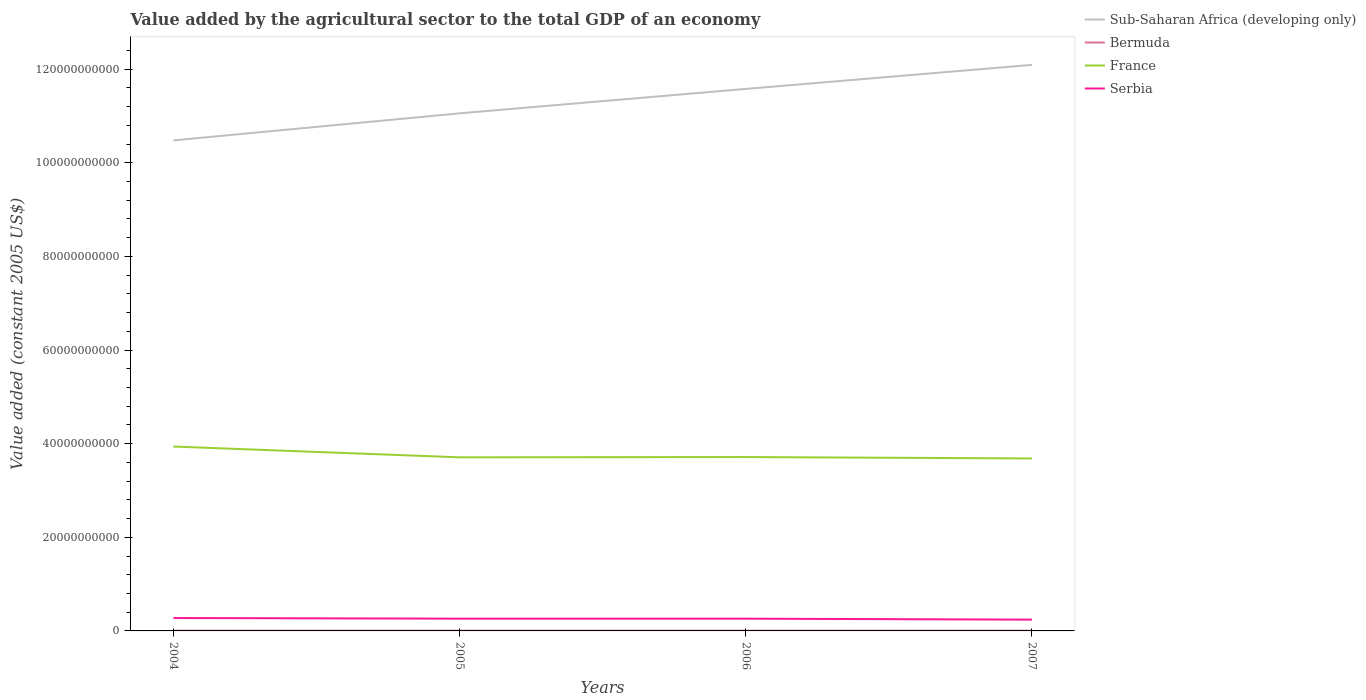How many different coloured lines are there?
Ensure brevity in your answer.  4. Is the number of lines equal to the number of legend labels?
Provide a short and direct response. Yes. Across all years, what is the maximum value added by the agricultural sector in Bermuda?
Offer a terse response. 3.85e+07. What is the total value added by the agricultural sector in Sub-Saharan Africa (developing only) in the graph?
Your answer should be very brief. -5.14e+09. What is the difference between the highest and the second highest value added by the agricultural sector in Bermuda?
Your answer should be compact. 5.64e+06. How many lines are there?
Give a very brief answer. 4. How many years are there in the graph?
Ensure brevity in your answer.  4. What is the difference between two consecutive major ticks on the Y-axis?
Offer a very short reply. 2.00e+1. Does the graph contain grids?
Your answer should be very brief. No. What is the title of the graph?
Your answer should be very brief. Value added by the agricultural sector to the total GDP of an economy. What is the label or title of the Y-axis?
Offer a terse response. Value added (constant 2005 US$). What is the Value added (constant 2005 US$) in Sub-Saharan Africa (developing only) in 2004?
Make the answer very short. 1.05e+11. What is the Value added (constant 2005 US$) of Bermuda in 2004?
Offer a very short reply. 3.85e+07. What is the Value added (constant 2005 US$) in France in 2004?
Offer a very short reply. 3.94e+1. What is the Value added (constant 2005 US$) in Serbia in 2004?
Make the answer very short. 2.75e+09. What is the Value added (constant 2005 US$) of Sub-Saharan Africa (developing only) in 2005?
Keep it short and to the point. 1.11e+11. What is the Value added (constant 2005 US$) of Bermuda in 2005?
Your answer should be very brief. 3.90e+07. What is the Value added (constant 2005 US$) in France in 2005?
Your response must be concise. 3.71e+1. What is the Value added (constant 2005 US$) of Serbia in 2005?
Your answer should be compact. 2.62e+09. What is the Value added (constant 2005 US$) in Sub-Saharan Africa (developing only) in 2006?
Keep it short and to the point. 1.16e+11. What is the Value added (constant 2005 US$) of Bermuda in 2006?
Keep it short and to the point. 4.24e+07. What is the Value added (constant 2005 US$) in France in 2006?
Ensure brevity in your answer.  3.71e+1. What is the Value added (constant 2005 US$) in Serbia in 2006?
Your answer should be compact. 2.62e+09. What is the Value added (constant 2005 US$) in Sub-Saharan Africa (developing only) in 2007?
Your answer should be very brief. 1.21e+11. What is the Value added (constant 2005 US$) in Bermuda in 2007?
Make the answer very short. 4.42e+07. What is the Value added (constant 2005 US$) of France in 2007?
Keep it short and to the point. 3.68e+1. What is the Value added (constant 2005 US$) in Serbia in 2007?
Your response must be concise. 2.41e+09. Across all years, what is the maximum Value added (constant 2005 US$) of Sub-Saharan Africa (developing only)?
Your answer should be very brief. 1.21e+11. Across all years, what is the maximum Value added (constant 2005 US$) of Bermuda?
Ensure brevity in your answer.  4.42e+07. Across all years, what is the maximum Value added (constant 2005 US$) of France?
Your answer should be very brief. 3.94e+1. Across all years, what is the maximum Value added (constant 2005 US$) of Serbia?
Give a very brief answer. 2.75e+09. Across all years, what is the minimum Value added (constant 2005 US$) of Sub-Saharan Africa (developing only)?
Your answer should be compact. 1.05e+11. Across all years, what is the minimum Value added (constant 2005 US$) of Bermuda?
Keep it short and to the point. 3.85e+07. Across all years, what is the minimum Value added (constant 2005 US$) in France?
Your answer should be compact. 3.68e+1. Across all years, what is the minimum Value added (constant 2005 US$) in Serbia?
Your response must be concise. 2.41e+09. What is the total Value added (constant 2005 US$) of Sub-Saharan Africa (developing only) in the graph?
Your answer should be compact. 4.52e+11. What is the total Value added (constant 2005 US$) of Bermuda in the graph?
Offer a terse response. 1.64e+08. What is the total Value added (constant 2005 US$) in France in the graph?
Offer a terse response. 1.50e+11. What is the total Value added (constant 2005 US$) of Serbia in the graph?
Provide a succinct answer. 1.04e+1. What is the difference between the Value added (constant 2005 US$) in Sub-Saharan Africa (developing only) in 2004 and that in 2005?
Provide a short and direct response. -5.78e+09. What is the difference between the Value added (constant 2005 US$) in Bermuda in 2004 and that in 2005?
Keep it short and to the point. -4.91e+05. What is the difference between the Value added (constant 2005 US$) of France in 2004 and that in 2005?
Offer a very short reply. 2.30e+09. What is the difference between the Value added (constant 2005 US$) of Serbia in 2004 and that in 2005?
Your answer should be very brief. 1.33e+08. What is the difference between the Value added (constant 2005 US$) of Sub-Saharan Africa (developing only) in 2004 and that in 2006?
Give a very brief answer. -1.10e+1. What is the difference between the Value added (constant 2005 US$) of Bermuda in 2004 and that in 2006?
Offer a very short reply. -3.91e+06. What is the difference between the Value added (constant 2005 US$) in France in 2004 and that in 2006?
Ensure brevity in your answer.  2.24e+09. What is the difference between the Value added (constant 2005 US$) in Serbia in 2004 and that in 2006?
Offer a very short reply. 1.35e+08. What is the difference between the Value added (constant 2005 US$) of Sub-Saharan Africa (developing only) in 2004 and that in 2007?
Your answer should be very brief. -1.61e+1. What is the difference between the Value added (constant 2005 US$) of Bermuda in 2004 and that in 2007?
Keep it short and to the point. -5.64e+06. What is the difference between the Value added (constant 2005 US$) in France in 2004 and that in 2007?
Ensure brevity in your answer.  2.54e+09. What is the difference between the Value added (constant 2005 US$) in Serbia in 2004 and that in 2007?
Keep it short and to the point. 3.42e+08. What is the difference between the Value added (constant 2005 US$) in Sub-Saharan Africa (developing only) in 2005 and that in 2006?
Offer a very short reply. -5.22e+09. What is the difference between the Value added (constant 2005 US$) of Bermuda in 2005 and that in 2006?
Provide a succinct answer. -3.42e+06. What is the difference between the Value added (constant 2005 US$) of France in 2005 and that in 2006?
Your response must be concise. -5.91e+07. What is the difference between the Value added (constant 2005 US$) in Serbia in 2005 and that in 2006?
Your answer should be very brief. 1.80e+06. What is the difference between the Value added (constant 2005 US$) of Sub-Saharan Africa (developing only) in 2005 and that in 2007?
Ensure brevity in your answer.  -1.04e+1. What is the difference between the Value added (constant 2005 US$) of Bermuda in 2005 and that in 2007?
Provide a short and direct response. -5.15e+06. What is the difference between the Value added (constant 2005 US$) in France in 2005 and that in 2007?
Ensure brevity in your answer.  2.43e+08. What is the difference between the Value added (constant 2005 US$) in Serbia in 2005 and that in 2007?
Provide a succinct answer. 2.08e+08. What is the difference between the Value added (constant 2005 US$) in Sub-Saharan Africa (developing only) in 2006 and that in 2007?
Your answer should be compact. -5.14e+09. What is the difference between the Value added (constant 2005 US$) in Bermuda in 2006 and that in 2007?
Provide a succinct answer. -1.73e+06. What is the difference between the Value added (constant 2005 US$) in France in 2006 and that in 2007?
Ensure brevity in your answer.  3.02e+08. What is the difference between the Value added (constant 2005 US$) in Serbia in 2006 and that in 2007?
Keep it short and to the point. 2.06e+08. What is the difference between the Value added (constant 2005 US$) of Sub-Saharan Africa (developing only) in 2004 and the Value added (constant 2005 US$) of Bermuda in 2005?
Your answer should be compact. 1.05e+11. What is the difference between the Value added (constant 2005 US$) in Sub-Saharan Africa (developing only) in 2004 and the Value added (constant 2005 US$) in France in 2005?
Your answer should be compact. 6.77e+1. What is the difference between the Value added (constant 2005 US$) in Sub-Saharan Africa (developing only) in 2004 and the Value added (constant 2005 US$) in Serbia in 2005?
Offer a very short reply. 1.02e+11. What is the difference between the Value added (constant 2005 US$) in Bermuda in 2004 and the Value added (constant 2005 US$) in France in 2005?
Your answer should be compact. -3.70e+1. What is the difference between the Value added (constant 2005 US$) of Bermuda in 2004 and the Value added (constant 2005 US$) of Serbia in 2005?
Provide a succinct answer. -2.58e+09. What is the difference between the Value added (constant 2005 US$) of France in 2004 and the Value added (constant 2005 US$) of Serbia in 2005?
Provide a succinct answer. 3.68e+1. What is the difference between the Value added (constant 2005 US$) in Sub-Saharan Africa (developing only) in 2004 and the Value added (constant 2005 US$) in Bermuda in 2006?
Your response must be concise. 1.05e+11. What is the difference between the Value added (constant 2005 US$) of Sub-Saharan Africa (developing only) in 2004 and the Value added (constant 2005 US$) of France in 2006?
Provide a short and direct response. 6.76e+1. What is the difference between the Value added (constant 2005 US$) in Sub-Saharan Africa (developing only) in 2004 and the Value added (constant 2005 US$) in Serbia in 2006?
Provide a short and direct response. 1.02e+11. What is the difference between the Value added (constant 2005 US$) in Bermuda in 2004 and the Value added (constant 2005 US$) in France in 2006?
Make the answer very short. -3.71e+1. What is the difference between the Value added (constant 2005 US$) of Bermuda in 2004 and the Value added (constant 2005 US$) of Serbia in 2006?
Your answer should be very brief. -2.58e+09. What is the difference between the Value added (constant 2005 US$) in France in 2004 and the Value added (constant 2005 US$) in Serbia in 2006?
Your answer should be compact. 3.68e+1. What is the difference between the Value added (constant 2005 US$) of Sub-Saharan Africa (developing only) in 2004 and the Value added (constant 2005 US$) of Bermuda in 2007?
Your answer should be compact. 1.05e+11. What is the difference between the Value added (constant 2005 US$) in Sub-Saharan Africa (developing only) in 2004 and the Value added (constant 2005 US$) in France in 2007?
Offer a terse response. 6.79e+1. What is the difference between the Value added (constant 2005 US$) in Sub-Saharan Africa (developing only) in 2004 and the Value added (constant 2005 US$) in Serbia in 2007?
Provide a succinct answer. 1.02e+11. What is the difference between the Value added (constant 2005 US$) in Bermuda in 2004 and the Value added (constant 2005 US$) in France in 2007?
Make the answer very short. -3.68e+1. What is the difference between the Value added (constant 2005 US$) of Bermuda in 2004 and the Value added (constant 2005 US$) of Serbia in 2007?
Offer a very short reply. -2.37e+09. What is the difference between the Value added (constant 2005 US$) in France in 2004 and the Value added (constant 2005 US$) in Serbia in 2007?
Provide a succinct answer. 3.70e+1. What is the difference between the Value added (constant 2005 US$) in Sub-Saharan Africa (developing only) in 2005 and the Value added (constant 2005 US$) in Bermuda in 2006?
Provide a succinct answer. 1.11e+11. What is the difference between the Value added (constant 2005 US$) of Sub-Saharan Africa (developing only) in 2005 and the Value added (constant 2005 US$) of France in 2006?
Make the answer very short. 7.34e+1. What is the difference between the Value added (constant 2005 US$) in Sub-Saharan Africa (developing only) in 2005 and the Value added (constant 2005 US$) in Serbia in 2006?
Offer a terse response. 1.08e+11. What is the difference between the Value added (constant 2005 US$) of Bermuda in 2005 and the Value added (constant 2005 US$) of France in 2006?
Offer a very short reply. -3.71e+1. What is the difference between the Value added (constant 2005 US$) in Bermuda in 2005 and the Value added (constant 2005 US$) in Serbia in 2006?
Your answer should be very brief. -2.58e+09. What is the difference between the Value added (constant 2005 US$) of France in 2005 and the Value added (constant 2005 US$) of Serbia in 2006?
Ensure brevity in your answer.  3.45e+1. What is the difference between the Value added (constant 2005 US$) of Sub-Saharan Africa (developing only) in 2005 and the Value added (constant 2005 US$) of Bermuda in 2007?
Offer a terse response. 1.11e+11. What is the difference between the Value added (constant 2005 US$) in Sub-Saharan Africa (developing only) in 2005 and the Value added (constant 2005 US$) in France in 2007?
Provide a short and direct response. 7.37e+1. What is the difference between the Value added (constant 2005 US$) in Sub-Saharan Africa (developing only) in 2005 and the Value added (constant 2005 US$) in Serbia in 2007?
Your answer should be very brief. 1.08e+11. What is the difference between the Value added (constant 2005 US$) of Bermuda in 2005 and the Value added (constant 2005 US$) of France in 2007?
Provide a succinct answer. -3.68e+1. What is the difference between the Value added (constant 2005 US$) in Bermuda in 2005 and the Value added (constant 2005 US$) in Serbia in 2007?
Ensure brevity in your answer.  -2.37e+09. What is the difference between the Value added (constant 2005 US$) of France in 2005 and the Value added (constant 2005 US$) of Serbia in 2007?
Provide a succinct answer. 3.47e+1. What is the difference between the Value added (constant 2005 US$) of Sub-Saharan Africa (developing only) in 2006 and the Value added (constant 2005 US$) of Bermuda in 2007?
Provide a short and direct response. 1.16e+11. What is the difference between the Value added (constant 2005 US$) in Sub-Saharan Africa (developing only) in 2006 and the Value added (constant 2005 US$) in France in 2007?
Offer a terse response. 7.89e+1. What is the difference between the Value added (constant 2005 US$) in Sub-Saharan Africa (developing only) in 2006 and the Value added (constant 2005 US$) in Serbia in 2007?
Offer a terse response. 1.13e+11. What is the difference between the Value added (constant 2005 US$) in Bermuda in 2006 and the Value added (constant 2005 US$) in France in 2007?
Offer a terse response. -3.68e+1. What is the difference between the Value added (constant 2005 US$) in Bermuda in 2006 and the Value added (constant 2005 US$) in Serbia in 2007?
Provide a succinct answer. -2.37e+09. What is the difference between the Value added (constant 2005 US$) of France in 2006 and the Value added (constant 2005 US$) of Serbia in 2007?
Offer a terse response. 3.47e+1. What is the average Value added (constant 2005 US$) in Sub-Saharan Africa (developing only) per year?
Provide a succinct answer. 1.13e+11. What is the average Value added (constant 2005 US$) of Bermuda per year?
Keep it short and to the point. 4.10e+07. What is the average Value added (constant 2005 US$) in France per year?
Keep it short and to the point. 3.76e+1. What is the average Value added (constant 2005 US$) of Serbia per year?
Provide a succinct answer. 2.60e+09. In the year 2004, what is the difference between the Value added (constant 2005 US$) in Sub-Saharan Africa (developing only) and Value added (constant 2005 US$) in Bermuda?
Provide a short and direct response. 1.05e+11. In the year 2004, what is the difference between the Value added (constant 2005 US$) in Sub-Saharan Africa (developing only) and Value added (constant 2005 US$) in France?
Offer a terse response. 6.54e+1. In the year 2004, what is the difference between the Value added (constant 2005 US$) of Sub-Saharan Africa (developing only) and Value added (constant 2005 US$) of Serbia?
Offer a terse response. 1.02e+11. In the year 2004, what is the difference between the Value added (constant 2005 US$) in Bermuda and Value added (constant 2005 US$) in France?
Keep it short and to the point. -3.93e+1. In the year 2004, what is the difference between the Value added (constant 2005 US$) of Bermuda and Value added (constant 2005 US$) of Serbia?
Keep it short and to the point. -2.71e+09. In the year 2004, what is the difference between the Value added (constant 2005 US$) in France and Value added (constant 2005 US$) in Serbia?
Offer a terse response. 3.66e+1. In the year 2005, what is the difference between the Value added (constant 2005 US$) of Sub-Saharan Africa (developing only) and Value added (constant 2005 US$) of Bermuda?
Ensure brevity in your answer.  1.11e+11. In the year 2005, what is the difference between the Value added (constant 2005 US$) of Sub-Saharan Africa (developing only) and Value added (constant 2005 US$) of France?
Keep it short and to the point. 7.35e+1. In the year 2005, what is the difference between the Value added (constant 2005 US$) in Sub-Saharan Africa (developing only) and Value added (constant 2005 US$) in Serbia?
Make the answer very short. 1.08e+11. In the year 2005, what is the difference between the Value added (constant 2005 US$) of Bermuda and Value added (constant 2005 US$) of France?
Offer a very short reply. -3.70e+1. In the year 2005, what is the difference between the Value added (constant 2005 US$) in Bermuda and Value added (constant 2005 US$) in Serbia?
Your response must be concise. -2.58e+09. In the year 2005, what is the difference between the Value added (constant 2005 US$) of France and Value added (constant 2005 US$) of Serbia?
Keep it short and to the point. 3.45e+1. In the year 2006, what is the difference between the Value added (constant 2005 US$) in Sub-Saharan Africa (developing only) and Value added (constant 2005 US$) in Bermuda?
Keep it short and to the point. 1.16e+11. In the year 2006, what is the difference between the Value added (constant 2005 US$) in Sub-Saharan Africa (developing only) and Value added (constant 2005 US$) in France?
Your answer should be compact. 7.86e+1. In the year 2006, what is the difference between the Value added (constant 2005 US$) in Sub-Saharan Africa (developing only) and Value added (constant 2005 US$) in Serbia?
Provide a succinct answer. 1.13e+11. In the year 2006, what is the difference between the Value added (constant 2005 US$) in Bermuda and Value added (constant 2005 US$) in France?
Provide a succinct answer. -3.71e+1. In the year 2006, what is the difference between the Value added (constant 2005 US$) of Bermuda and Value added (constant 2005 US$) of Serbia?
Offer a very short reply. -2.58e+09. In the year 2006, what is the difference between the Value added (constant 2005 US$) in France and Value added (constant 2005 US$) in Serbia?
Provide a short and direct response. 3.45e+1. In the year 2007, what is the difference between the Value added (constant 2005 US$) of Sub-Saharan Africa (developing only) and Value added (constant 2005 US$) of Bermuda?
Provide a short and direct response. 1.21e+11. In the year 2007, what is the difference between the Value added (constant 2005 US$) of Sub-Saharan Africa (developing only) and Value added (constant 2005 US$) of France?
Ensure brevity in your answer.  8.41e+1. In the year 2007, what is the difference between the Value added (constant 2005 US$) of Sub-Saharan Africa (developing only) and Value added (constant 2005 US$) of Serbia?
Your response must be concise. 1.19e+11. In the year 2007, what is the difference between the Value added (constant 2005 US$) of Bermuda and Value added (constant 2005 US$) of France?
Provide a short and direct response. -3.68e+1. In the year 2007, what is the difference between the Value added (constant 2005 US$) of Bermuda and Value added (constant 2005 US$) of Serbia?
Give a very brief answer. -2.37e+09. In the year 2007, what is the difference between the Value added (constant 2005 US$) of France and Value added (constant 2005 US$) of Serbia?
Provide a short and direct response. 3.44e+1. What is the ratio of the Value added (constant 2005 US$) in Sub-Saharan Africa (developing only) in 2004 to that in 2005?
Ensure brevity in your answer.  0.95. What is the ratio of the Value added (constant 2005 US$) in Bermuda in 2004 to that in 2005?
Ensure brevity in your answer.  0.99. What is the ratio of the Value added (constant 2005 US$) in France in 2004 to that in 2005?
Offer a very short reply. 1.06. What is the ratio of the Value added (constant 2005 US$) in Serbia in 2004 to that in 2005?
Your response must be concise. 1.05. What is the ratio of the Value added (constant 2005 US$) in Sub-Saharan Africa (developing only) in 2004 to that in 2006?
Offer a very short reply. 0.91. What is the ratio of the Value added (constant 2005 US$) of Bermuda in 2004 to that in 2006?
Keep it short and to the point. 0.91. What is the ratio of the Value added (constant 2005 US$) of France in 2004 to that in 2006?
Give a very brief answer. 1.06. What is the ratio of the Value added (constant 2005 US$) in Serbia in 2004 to that in 2006?
Keep it short and to the point. 1.05. What is the ratio of the Value added (constant 2005 US$) in Sub-Saharan Africa (developing only) in 2004 to that in 2007?
Your response must be concise. 0.87. What is the ratio of the Value added (constant 2005 US$) in Bermuda in 2004 to that in 2007?
Make the answer very short. 0.87. What is the ratio of the Value added (constant 2005 US$) of France in 2004 to that in 2007?
Keep it short and to the point. 1.07. What is the ratio of the Value added (constant 2005 US$) in Serbia in 2004 to that in 2007?
Keep it short and to the point. 1.14. What is the ratio of the Value added (constant 2005 US$) in Sub-Saharan Africa (developing only) in 2005 to that in 2006?
Provide a succinct answer. 0.95. What is the ratio of the Value added (constant 2005 US$) in Bermuda in 2005 to that in 2006?
Offer a very short reply. 0.92. What is the ratio of the Value added (constant 2005 US$) of Serbia in 2005 to that in 2006?
Your response must be concise. 1. What is the ratio of the Value added (constant 2005 US$) in Sub-Saharan Africa (developing only) in 2005 to that in 2007?
Provide a succinct answer. 0.91. What is the ratio of the Value added (constant 2005 US$) of Bermuda in 2005 to that in 2007?
Ensure brevity in your answer.  0.88. What is the ratio of the Value added (constant 2005 US$) in France in 2005 to that in 2007?
Make the answer very short. 1.01. What is the ratio of the Value added (constant 2005 US$) in Serbia in 2005 to that in 2007?
Your response must be concise. 1.09. What is the ratio of the Value added (constant 2005 US$) of Sub-Saharan Africa (developing only) in 2006 to that in 2007?
Your answer should be very brief. 0.96. What is the ratio of the Value added (constant 2005 US$) in Bermuda in 2006 to that in 2007?
Provide a succinct answer. 0.96. What is the ratio of the Value added (constant 2005 US$) of France in 2006 to that in 2007?
Offer a terse response. 1.01. What is the ratio of the Value added (constant 2005 US$) of Serbia in 2006 to that in 2007?
Keep it short and to the point. 1.09. What is the difference between the highest and the second highest Value added (constant 2005 US$) in Sub-Saharan Africa (developing only)?
Provide a succinct answer. 5.14e+09. What is the difference between the highest and the second highest Value added (constant 2005 US$) of Bermuda?
Offer a very short reply. 1.73e+06. What is the difference between the highest and the second highest Value added (constant 2005 US$) in France?
Your answer should be very brief. 2.24e+09. What is the difference between the highest and the second highest Value added (constant 2005 US$) of Serbia?
Provide a succinct answer. 1.33e+08. What is the difference between the highest and the lowest Value added (constant 2005 US$) in Sub-Saharan Africa (developing only)?
Make the answer very short. 1.61e+1. What is the difference between the highest and the lowest Value added (constant 2005 US$) of Bermuda?
Your response must be concise. 5.64e+06. What is the difference between the highest and the lowest Value added (constant 2005 US$) in France?
Keep it short and to the point. 2.54e+09. What is the difference between the highest and the lowest Value added (constant 2005 US$) in Serbia?
Offer a terse response. 3.42e+08. 